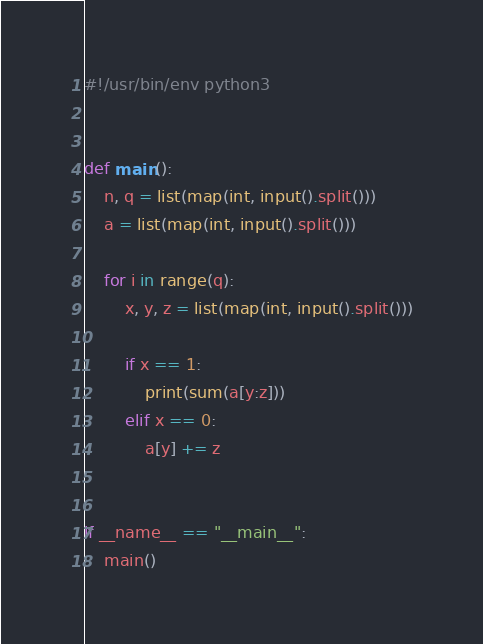Convert code to text. <code><loc_0><loc_0><loc_500><loc_500><_Python_>#!/usr/bin/env python3


def main():
    n, q = list(map(int, input().split()))
    a = list(map(int, input().split()))

    for i in range(q):
        x, y, z = list(map(int, input().split()))

        if x == 1:
            print(sum(a[y:z]))
        elif x == 0:
            a[y] += z


if __name__ == "__main__":
    main()
</code> 